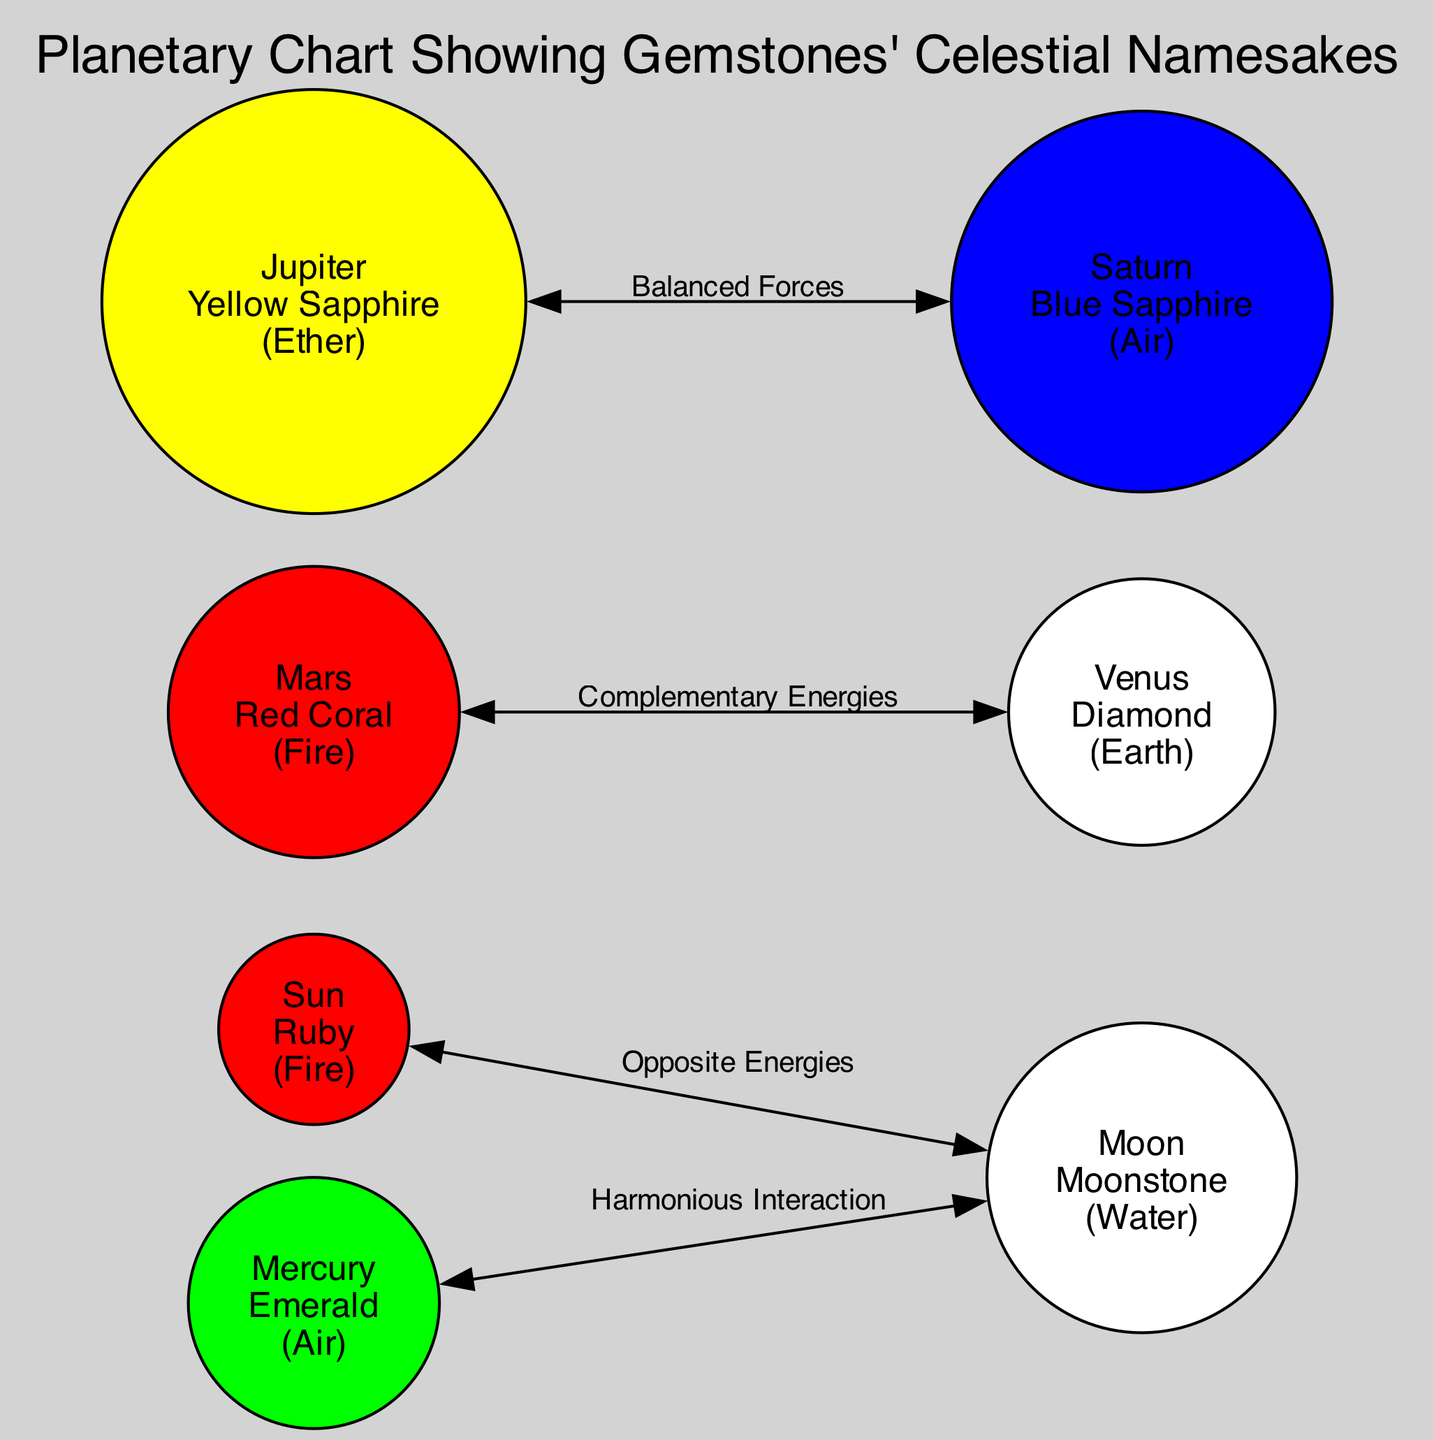What gemstone is associated with the Sun? The diagram shows that the Sun is linked with the gemstone Ruby, as indicated in the description for the Sun node.
Answer: Ruby What color represents Mercury? According to the node information, Mercury is represented by the color Green, as specified in its description.
Answer: Green What relationship exists between Mars and Venus? The diagram illustrates that Mars and Venus have a relationship labeled as "Complementary Energies," which connects their nodes directly.
Answer: Complementary Energies How many nodes are in the diagram? By counting the individual nodes listed in the data section, there are a total of 7 nodes representing different celestial bodies and their gemstones.
Answer: 7 Which gemstone corresponds to Jupiter? The Jupiter node indicates that it is associated with the Yellow Sapphire gemstone, as detailed in its description.
Answer: Yellow Sapphire What element is associated with Saturn? The diagram indicates that Saturn is linked to the Air element, as provided in its node description.
Answer: Air Which two nodes have a "Balanced Forces" relationship? The diagram shows that there is a direct connection labeled "Balanced Forces" between the Jupiter and Saturn nodes, indicating their relationship.
Answer: Jupiter and Saturn What is the color of the Moonstone? The description for the Moon node states that Moonstone is associated with the color White, thus giving a clear identification of its color.
Answer: White What type of interaction exists between Mercury and the Moon? The diagram specifies that the relationship between Mercury and the Moon is defined as "Harmonious Interaction," showing their connection type in the diagram.
Answer: Harmonious Interaction 